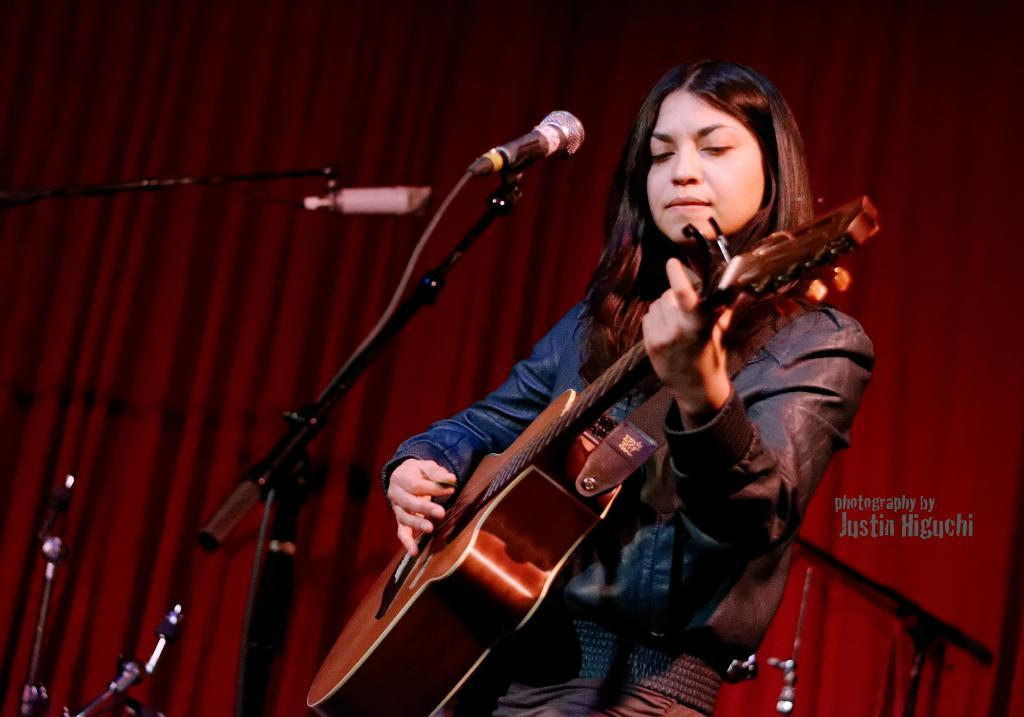What is the person in the image doing? The person is playing a guitar. What can be seen in the background of the image? There is a red curtain in the background of the image. What equipment is visible on the left side of the image? There are microphones on the left side of the image. What type of comb is being used by the person in the image? There is no comb visible in the image; the person is playing a guitar. 